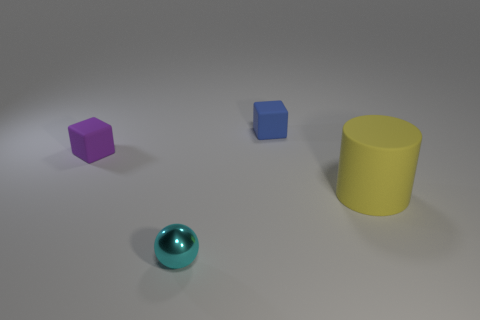Add 1 metallic balls. How many objects exist? 5 Subtract all cylinders. How many objects are left? 3 Subtract 0 cyan cubes. How many objects are left? 4 Subtract all yellow rubber cylinders. Subtract all cyan shiny things. How many objects are left? 2 Add 3 tiny blue rubber blocks. How many tiny blue rubber blocks are left? 4 Add 2 metallic cubes. How many metallic cubes exist? 2 